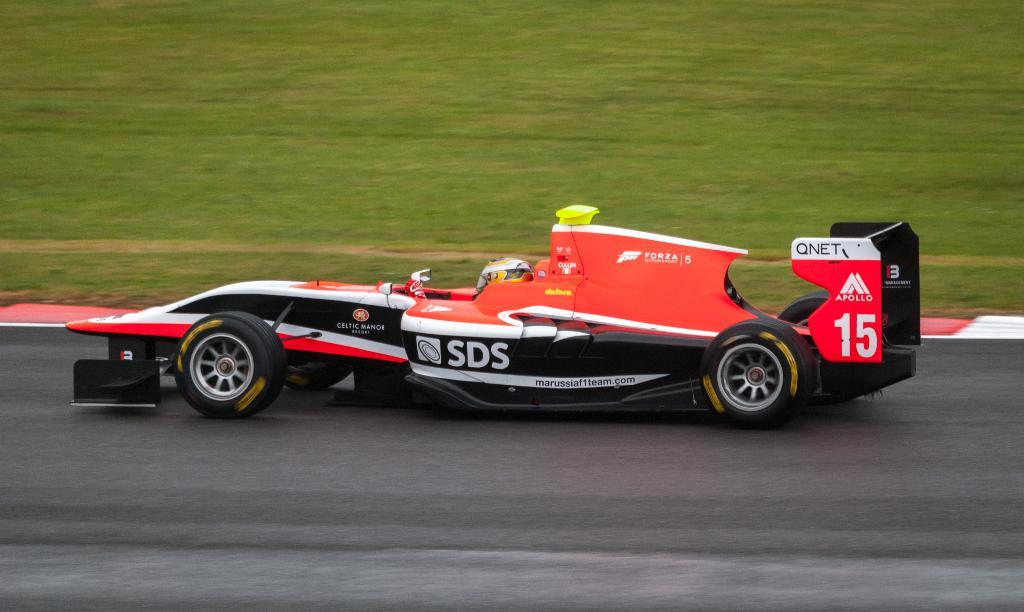What is the main subject of the image? The main subject of the image is a car on the road. What can be seen in the background of the image? There is grassy land visible at the top of the image. Is there anyone inside the car? Yes, there is a person in the car. What type of linen is draped over the horse in the image? There is no horse or linen present in the image; it features a car on the road with a person inside. What sound do the bells make in the image? There are no bells present in the image. 